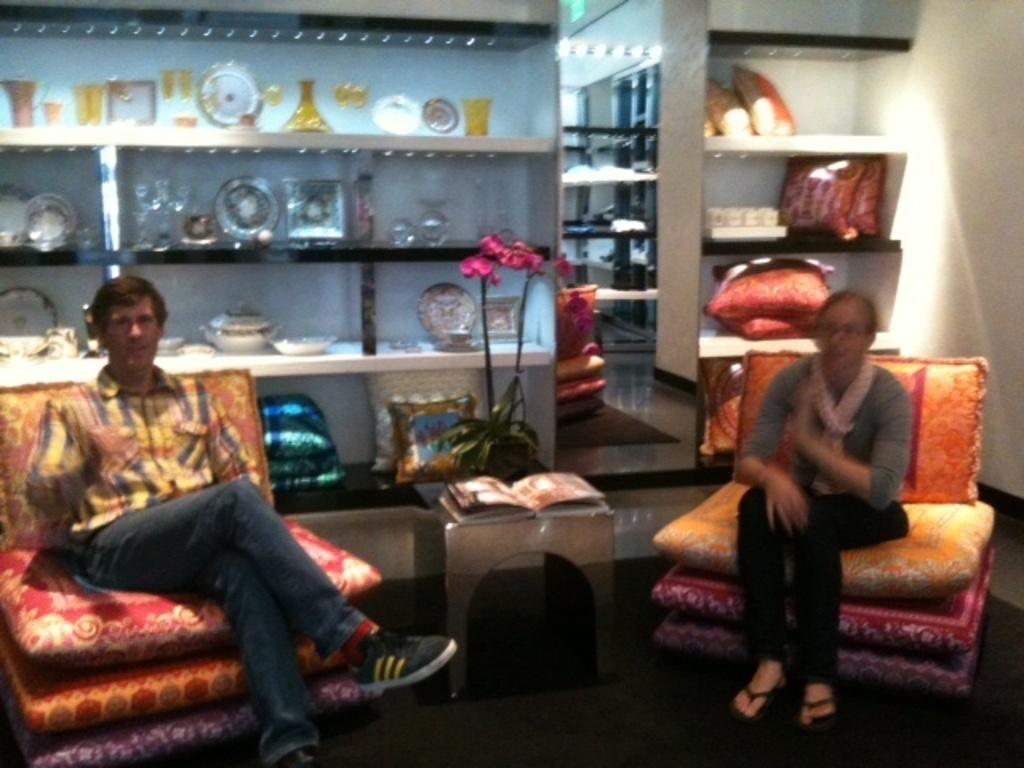What are the two people in the image doing? There is a man and a woman sitting in the image. What can be seen in the background of the image? There is a book, a flower, and cushions in the background of the image. What is the acoustics like in the room where the group is sitting in the image? There is no group present in the image, and the acoustics of the room cannot be determined from the image. 